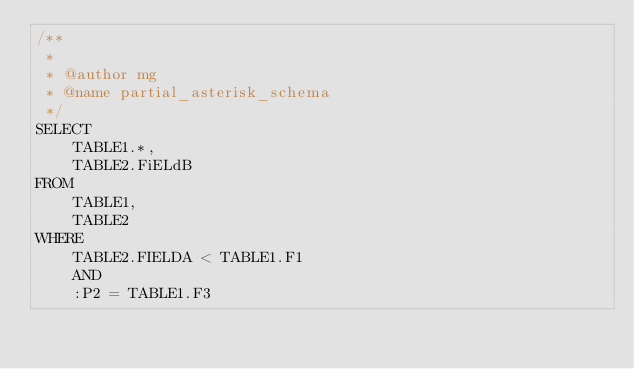<code> <loc_0><loc_0><loc_500><loc_500><_SQL_>/**
 * 
 * @author mg
 * @name partial_asterisk_schema
 */
SELECT
    TABLE1.*,
    TABLE2.FiELdB
FROM
    TABLE1,
    TABLE2
WHERE
    TABLE2.FIELDA < TABLE1.F1
    AND
    :P2 = TABLE1.F3
</code> 